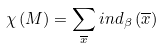<formula> <loc_0><loc_0><loc_500><loc_500>\chi \left ( M \right ) = \sum _ { \overline { x } } i n d _ { \beta } \left ( \overline { x } \right )</formula> 